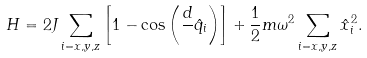<formula> <loc_0><loc_0><loc_500><loc_500>H = 2 J \sum _ { i = x , y , z } \left [ 1 - \cos \left ( \frac { d } { } \hat { q } _ { i } \right ) \right ] + \frac { 1 } { 2 } m \omega ^ { 2 } \sum _ { i = x , y , z } \hat { x } _ { i } ^ { 2 } .</formula> 